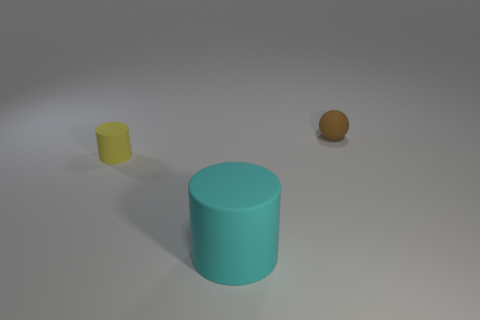Add 2 large blue objects. How many objects exist? 5 Subtract all spheres. How many objects are left? 2 Subtract all big things. Subtract all big green metal objects. How many objects are left? 2 Add 2 big cylinders. How many big cylinders are left? 3 Add 3 big cyan rubber cylinders. How many big cyan rubber cylinders exist? 4 Subtract 0 yellow balls. How many objects are left? 3 